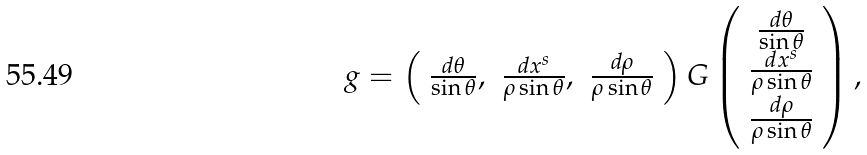<formula> <loc_0><loc_0><loc_500><loc_500>g = \left ( \begin{array} { c c c } \frac { d \theta } { \sin \theta } , & \frac { d x ^ { s } } { \rho \sin \theta } , & \frac { d \rho } { \rho \sin \theta } \end{array} \right ) G \left ( \begin{array} { c c c } \frac { d \theta } { \sin \theta } \\ \frac { d x ^ { s } } { \rho \sin \theta } \\ \frac { d \rho } { \rho \sin \theta } \end{array} \right ) ,</formula> 